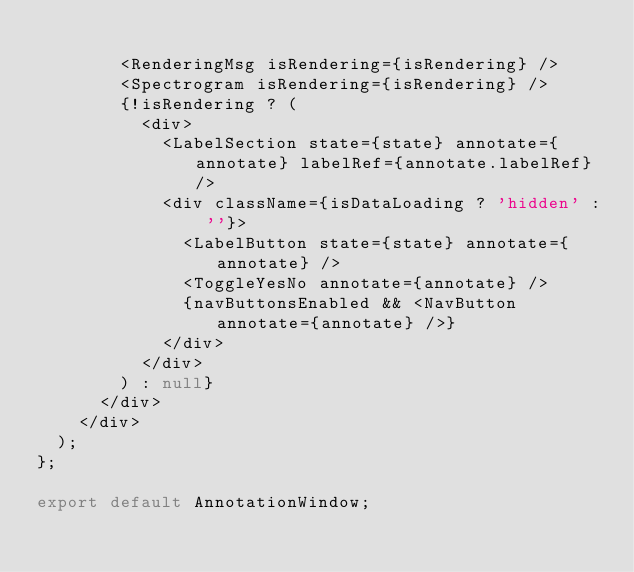Convert code to text. <code><loc_0><loc_0><loc_500><loc_500><_JavaScript_>
        <RenderingMsg isRendering={isRendering} />
        <Spectrogram isRendering={isRendering} />
        {!isRendering ? (
          <div>
            <LabelSection state={state} annotate={annotate} labelRef={annotate.labelRef} />
            <div className={isDataLoading ? 'hidden' : ''}>
              <LabelButton state={state} annotate={annotate} />
              <ToggleYesNo annotate={annotate} />
              {navButtonsEnabled && <NavButton annotate={annotate} />}
            </div>
          </div>
        ) : null}
      </div>
    </div>
  );
};

export default AnnotationWindow;
</code> 